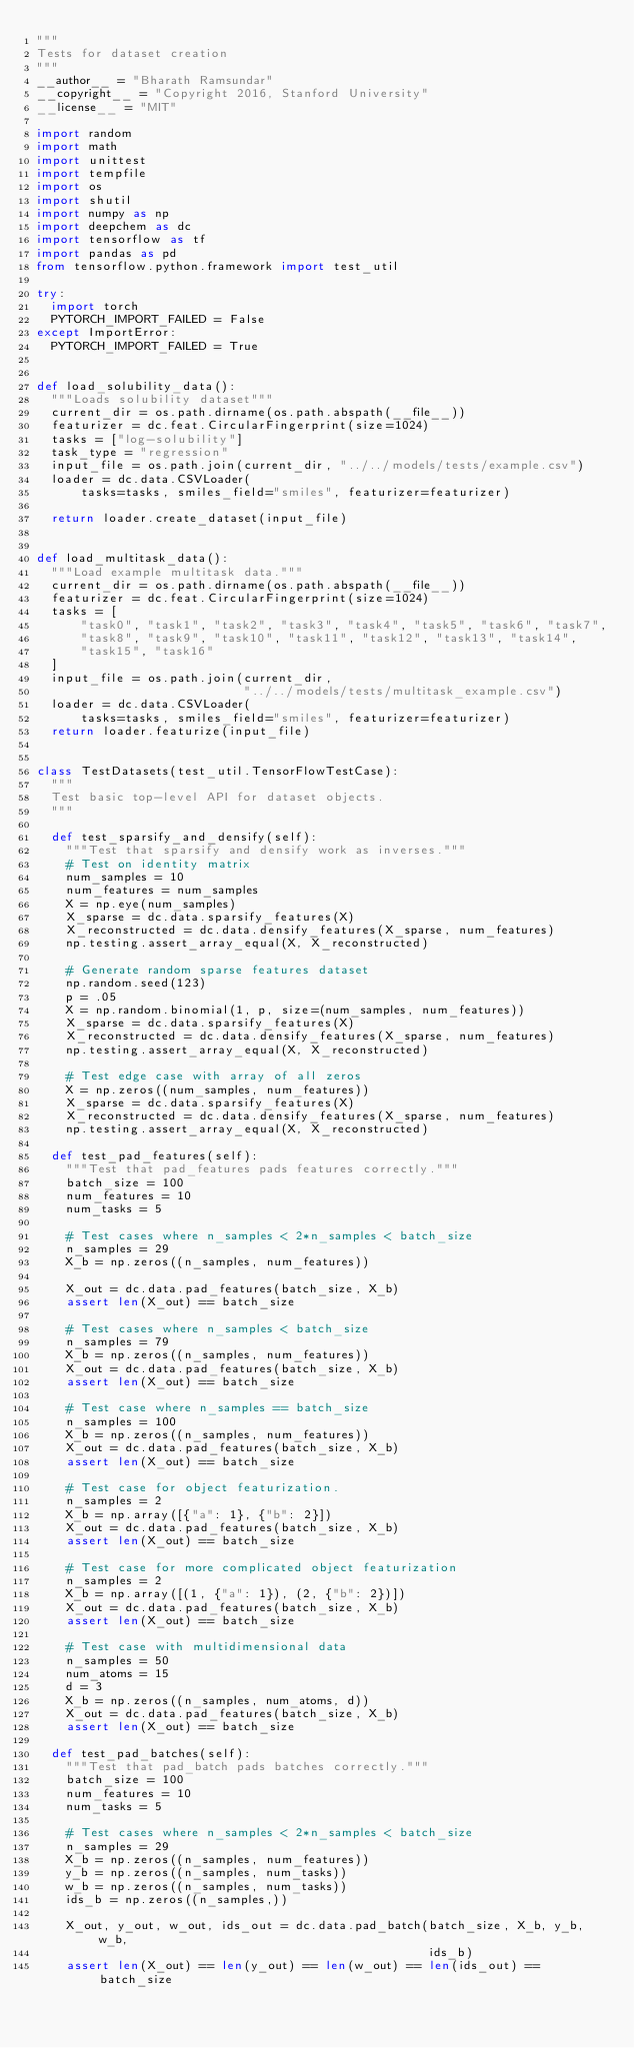Convert code to text. <code><loc_0><loc_0><loc_500><loc_500><_Python_>"""
Tests for dataset creation
"""
__author__ = "Bharath Ramsundar"
__copyright__ = "Copyright 2016, Stanford University"
__license__ = "MIT"

import random
import math
import unittest
import tempfile
import os
import shutil
import numpy as np
import deepchem as dc
import tensorflow as tf
import pandas as pd
from tensorflow.python.framework import test_util

try:
  import torch
  PYTORCH_IMPORT_FAILED = False
except ImportError:
  PYTORCH_IMPORT_FAILED = True


def load_solubility_data():
  """Loads solubility dataset"""
  current_dir = os.path.dirname(os.path.abspath(__file__))
  featurizer = dc.feat.CircularFingerprint(size=1024)
  tasks = ["log-solubility"]
  task_type = "regression"
  input_file = os.path.join(current_dir, "../../models/tests/example.csv")
  loader = dc.data.CSVLoader(
      tasks=tasks, smiles_field="smiles", featurizer=featurizer)

  return loader.create_dataset(input_file)


def load_multitask_data():
  """Load example multitask data."""
  current_dir = os.path.dirname(os.path.abspath(__file__))
  featurizer = dc.feat.CircularFingerprint(size=1024)
  tasks = [
      "task0", "task1", "task2", "task3", "task4", "task5", "task6", "task7",
      "task8", "task9", "task10", "task11", "task12", "task13", "task14",
      "task15", "task16"
  ]
  input_file = os.path.join(current_dir,
                            "../../models/tests/multitask_example.csv")
  loader = dc.data.CSVLoader(
      tasks=tasks, smiles_field="smiles", featurizer=featurizer)
  return loader.featurize(input_file)


class TestDatasets(test_util.TensorFlowTestCase):
  """
  Test basic top-level API for dataset objects.
  """

  def test_sparsify_and_densify(self):
    """Test that sparsify and densify work as inverses."""
    # Test on identity matrix
    num_samples = 10
    num_features = num_samples
    X = np.eye(num_samples)
    X_sparse = dc.data.sparsify_features(X)
    X_reconstructed = dc.data.densify_features(X_sparse, num_features)
    np.testing.assert_array_equal(X, X_reconstructed)

    # Generate random sparse features dataset
    np.random.seed(123)
    p = .05
    X = np.random.binomial(1, p, size=(num_samples, num_features))
    X_sparse = dc.data.sparsify_features(X)
    X_reconstructed = dc.data.densify_features(X_sparse, num_features)
    np.testing.assert_array_equal(X, X_reconstructed)

    # Test edge case with array of all zeros
    X = np.zeros((num_samples, num_features))
    X_sparse = dc.data.sparsify_features(X)
    X_reconstructed = dc.data.densify_features(X_sparse, num_features)
    np.testing.assert_array_equal(X, X_reconstructed)

  def test_pad_features(self):
    """Test that pad_features pads features correctly."""
    batch_size = 100
    num_features = 10
    num_tasks = 5

    # Test cases where n_samples < 2*n_samples < batch_size
    n_samples = 29
    X_b = np.zeros((n_samples, num_features))

    X_out = dc.data.pad_features(batch_size, X_b)
    assert len(X_out) == batch_size

    # Test cases where n_samples < batch_size
    n_samples = 79
    X_b = np.zeros((n_samples, num_features))
    X_out = dc.data.pad_features(batch_size, X_b)
    assert len(X_out) == batch_size

    # Test case where n_samples == batch_size
    n_samples = 100
    X_b = np.zeros((n_samples, num_features))
    X_out = dc.data.pad_features(batch_size, X_b)
    assert len(X_out) == batch_size

    # Test case for object featurization.
    n_samples = 2
    X_b = np.array([{"a": 1}, {"b": 2}])
    X_out = dc.data.pad_features(batch_size, X_b)
    assert len(X_out) == batch_size

    # Test case for more complicated object featurization
    n_samples = 2
    X_b = np.array([(1, {"a": 1}), (2, {"b": 2})])
    X_out = dc.data.pad_features(batch_size, X_b)
    assert len(X_out) == batch_size

    # Test case with multidimensional data
    n_samples = 50
    num_atoms = 15
    d = 3
    X_b = np.zeros((n_samples, num_atoms, d))
    X_out = dc.data.pad_features(batch_size, X_b)
    assert len(X_out) == batch_size

  def test_pad_batches(self):
    """Test that pad_batch pads batches correctly."""
    batch_size = 100
    num_features = 10
    num_tasks = 5

    # Test cases where n_samples < 2*n_samples < batch_size
    n_samples = 29
    X_b = np.zeros((n_samples, num_features))
    y_b = np.zeros((n_samples, num_tasks))
    w_b = np.zeros((n_samples, num_tasks))
    ids_b = np.zeros((n_samples,))

    X_out, y_out, w_out, ids_out = dc.data.pad_batch(batch_size, X_b, y_b, w_b,
                                                     ids_b)
    assert len(X_out) == len(y_out) == len(w_out) == len(ids_out) == batch_size
</code> 